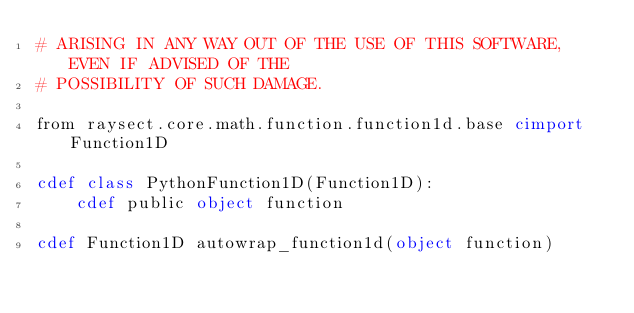Convert code to text. <code><loc_0><loc_0><loc_500><loc_500><_Cython_># ARISING IN ANY WAY OUT OF THE USE OF THIS SOFTWARE, EVEN IF ADVISED OF THE
# POSSIBILITY OF SUCH DAMAGE.

from raysect.core.math.function.function1d.base cimport Function1D

cdef class PythonFunction1D(Function1D):
    cdef public object function

cdef Function1D autowrap_function1d(object function)
</code> 